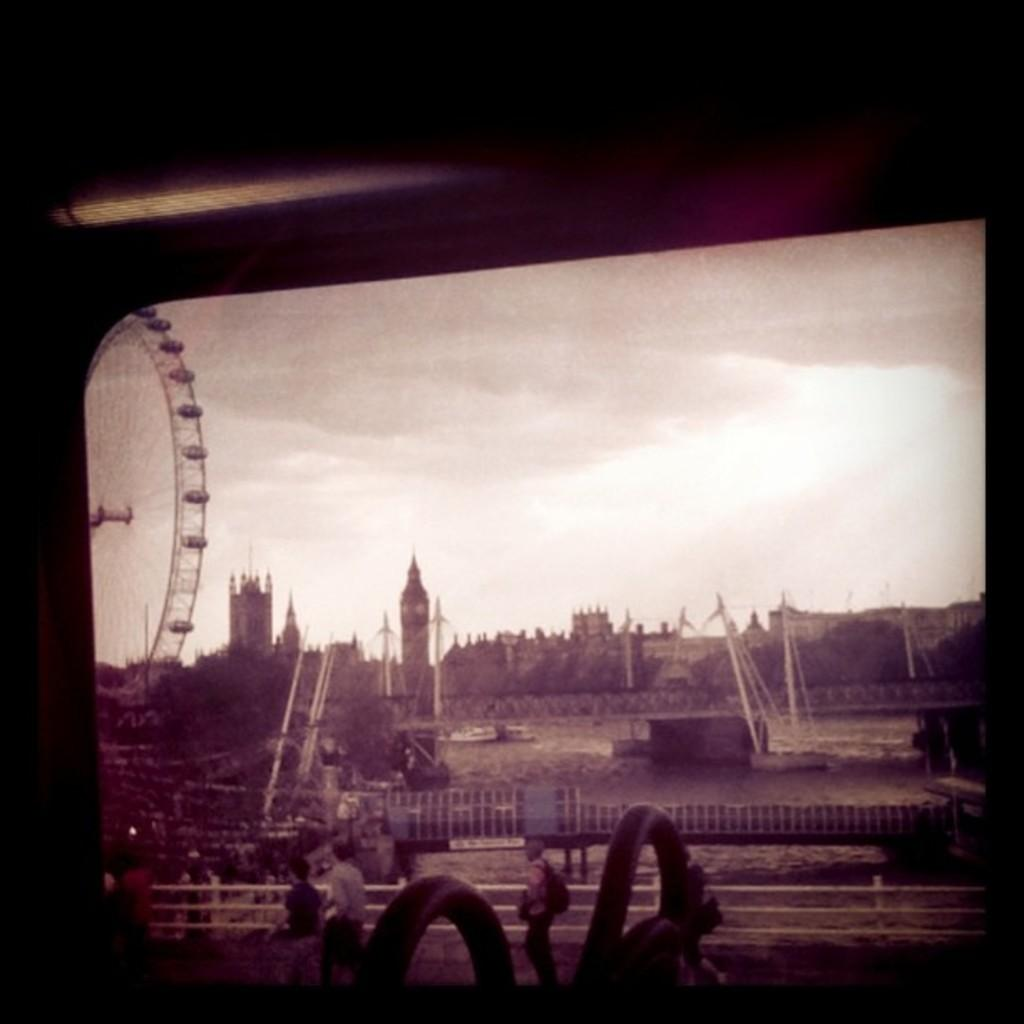What is the color scheme of the image? The image is black and white. What can be seen in the foreground of the image? There is a road in the image. What is happening in the background of the image? People are walking on the road, and there are poles visible in the background. What other objects can be seen in the background? A jet wheel and the sky are visible in the background. How many tomatoes are hanging from the poles in the image? There are no tomatoes present in the image; the poles are not associated with any tomatoes. What type of clock is visible on the road in the image? There is no clock visible in the image; the focus is on the road, people walking, poles, a jet wheel, and the sky. 